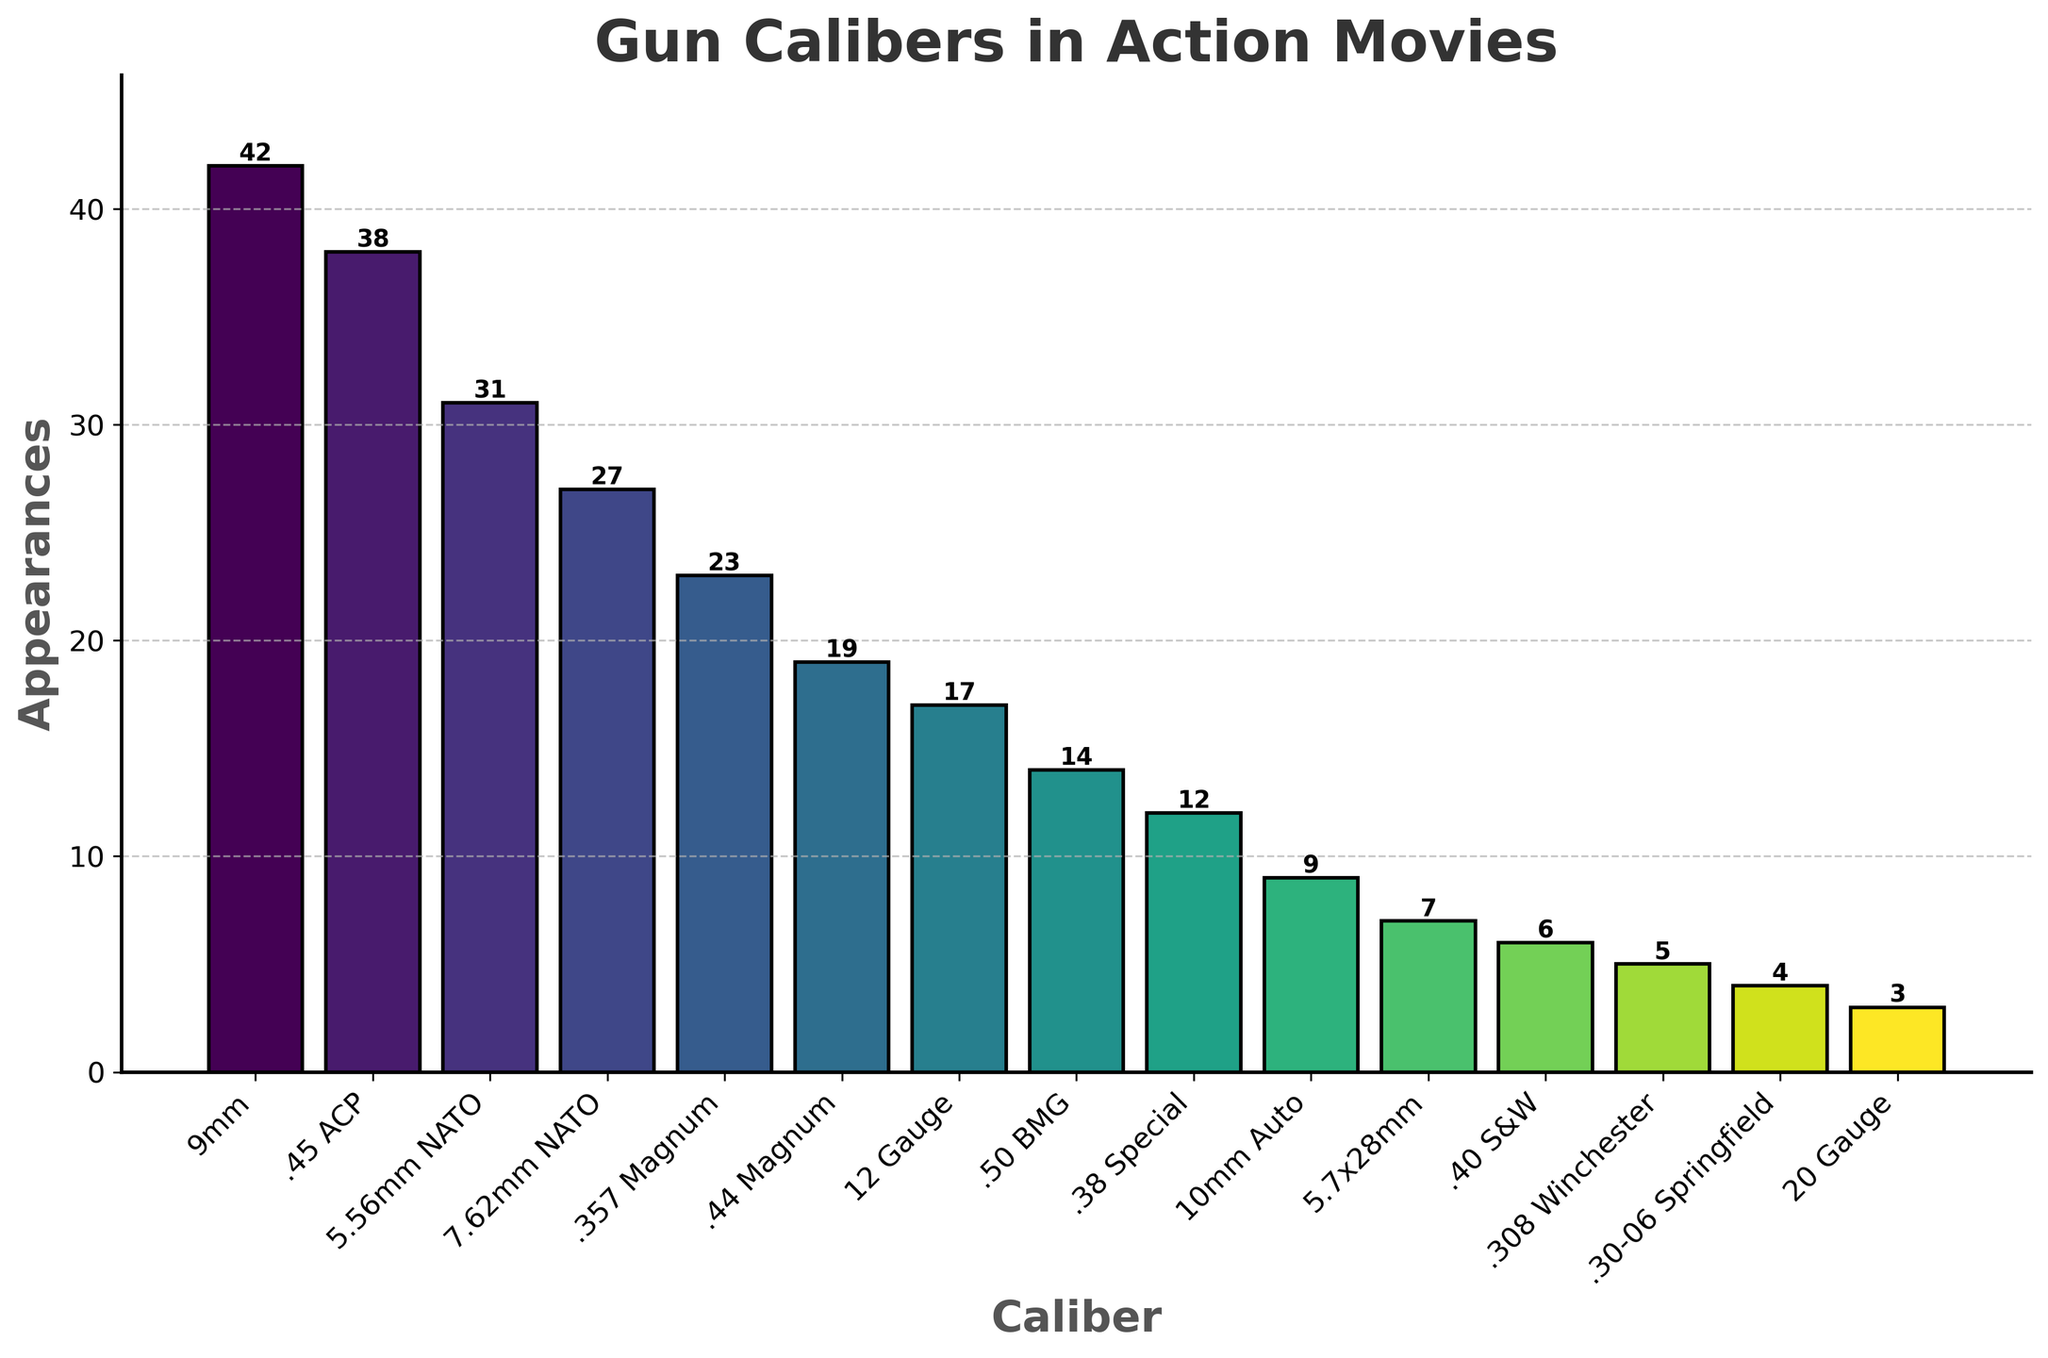What's the most common gun caliber in action movies? The tallest bar in the chart represents the most common gun caliber. In this case, the 9mm caliber has the tallest bar, indicating it has the most appearances.
Answer: 9mm Which gun caliber is more commonly used, .45 ACP or 7.62mm NATO? Compare the height of the bars for .45 ACP and 7.62mm NATO. The bar for .45 ACP is taller with 38 appearances, compared to 27 appearances for 7.62mm NATO.
Answer: .45 ACP How many more times does the 9mm caliber appear compared to the .38 Special? Subtract the number of appearances for .38 Special (12) from those of 9mm (42): 42 - 12 = 30.
Answer: 30 What's the total number of appearances for the three most common calibers? Add the number of appearances for 9mm (42), .45 ACP (38), and 5.56mm NATO (31): 42 + 38 + 31 = 111.
Answer: 111 What's the combined total of appearances for 12 Gauge and 20 Gauge? Add the number of appearances for 12 Gauge (17) and 20 Gauge (3): 17 + 3 = 20.
Answer: 20 Which caliber has fewer than 10 appearances? Look for bars with a height less than 10. The calibers with fewer than 10 appearances are 10mm Auto (9), 5.7x28mm (7), .40 S&W (6), .308 Winchester (5), .30-06 Springfield (4), and 20 Gauge (3).
Answer: 10mm Auto, 5.7x28mm, .40 S&W, .308 Winchester, .30-06 Springfield, 20 Gauge Is the 5.56mm NATO caliber more or less popular than the .357 Magnum? Compare the heights of their bars. The 5.56mm NATO bar with 31 appearances is taller than the .357 Magnum bar with 23 appearances, indicating it is more popular.
Answer: More popular Approximate how much higher is the 9mm bar compared to the .50 BMG bar? The difference in appearances is 42 (9mm) - 14 (.50 BMG) = 28. Visually, the 9mm bar is approximately three times higher than the .50 BMG bar.
Answer: Approximately three times higher 